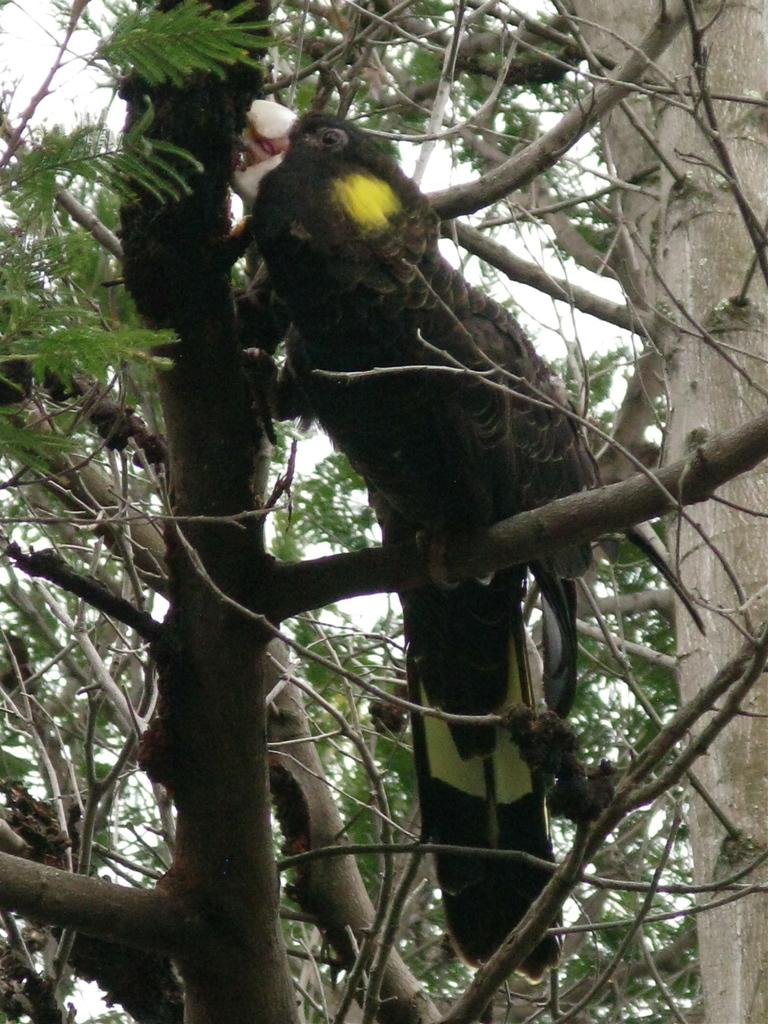What is present in the image besides the sky? There is a tree in the image. Is there anything on the tree? Yes, there is a bird on the tree. What can be seen behind the tree? The sky is visible behind the tree. How many sisters are sitting under the tree in the image? There are no sisters present in the image; it only features a tree and a bird. Is there an apple hanging from the tree in the image? There is no apple visible in the image; only a bird is present on the tree. 